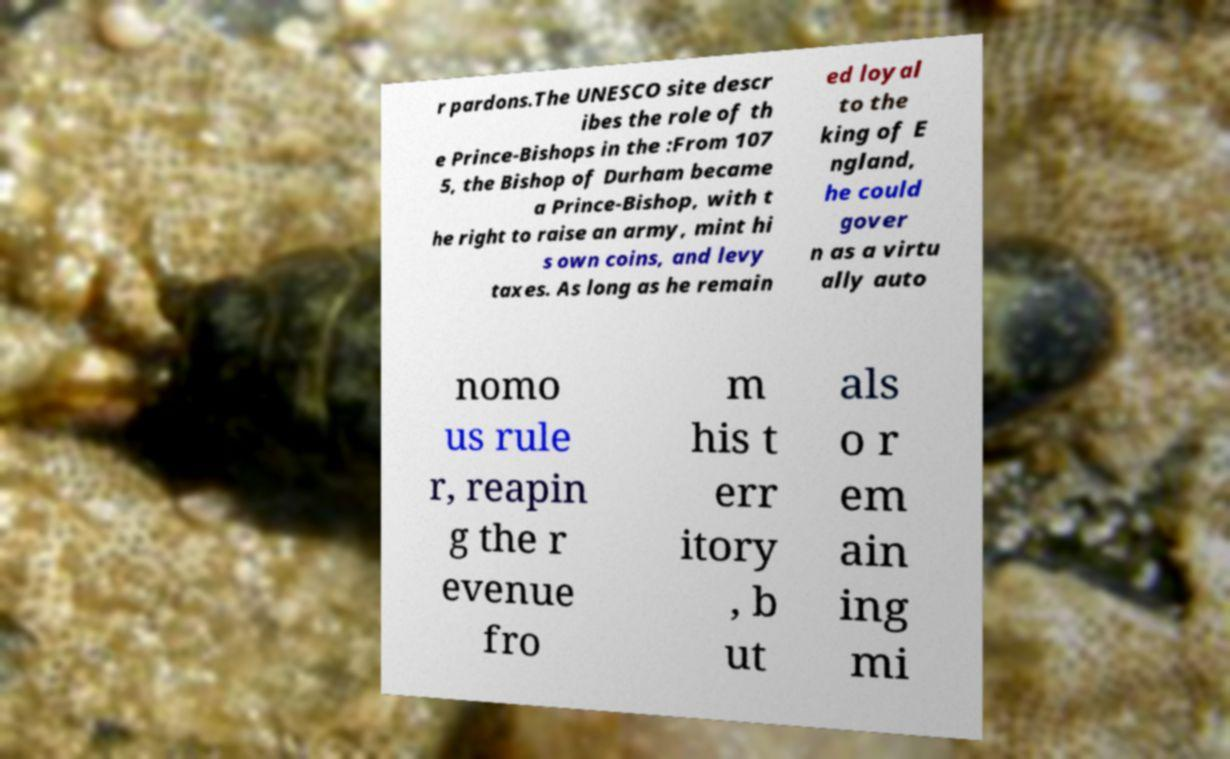Could you assist in decoding the text presented in this image and type it out clearly? r pardons.The UNESCO site descr ibes the role of th e Prince-Bishops in the :From 107 5, the Bishop of Durham became a Prince-Bishop, with t he right to raise an army, mint hi s own coins, and levy taxes. As long as he remain ed loyal to the king of E ngland, he could gover n as a virtu ally auto nomo us rule r, reapin g the r evenue fro m his t err itory , b ut als o r em ain ing mi 